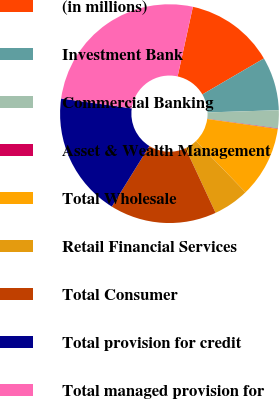Convert chart to OTSL. <chart><loc_0><loc_0><loc_500><loc_500><pie_chart><fcel>(in millions)<fcel>Investment Bank<fcel>Commercial Banking<fcel>Asset & Wealth Management<fcel>Total Wholesale<fcel>Retail Financial Services<fcel>Total Consumer<fcel>Total provision for credit<fcel>Total managed provision for<nl><fcel>13.15%<fcel>7.91%<fcel>2.68%<fcel>0.07%<fcel>10.53%<fcel>5.3%<fcel>15.76%<fcel>18.38%<fcel>26.22%<nl></chart> 